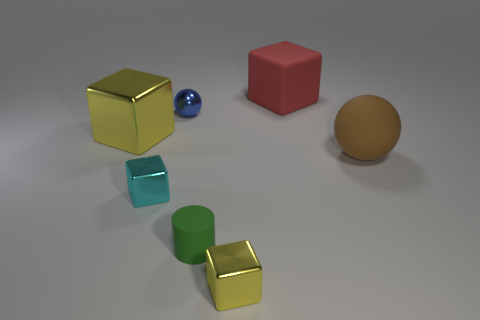What is the size of the yellow metal cube that is to the left of the sphere on the left side of the big red block?
Offer a very short reply. Large. Are there an equal number of cyan shiny cubes that are on the right side of the big red thing and tiny objects that are to the left of the small green rubber cylinder?
Give a very brief answer. No. There is a large object that is on the right side of the red cube; are there any metal cubes that are behind it?
Provide a succinct answer. Yes. There is a object that is behind the shiny object that is behind the big metallic object; what number of large cubes are to the left of it?
Your response must be concise. 1. Are there fewer brown spheres than small blue rubber cubes?
Offer a very short reply. No. There is a yellow object to the left of the blue object; is it the same shape as the small metal thing that is in front of the cyan metallic object?
Your answer should be compact. Yes. What is the color of the tiny metallic ball?
Provide a succinct answer. Blue. What number of metallic objects are either blue objects or tiny objects?
Give a very brief answer. 3. What is the color of the big metallic thing that is the same shape as the tiny cyan object?
Your answer should be very brief. Yellow. Is there a big gray matte cylinder?
Your response must be concise. No. 